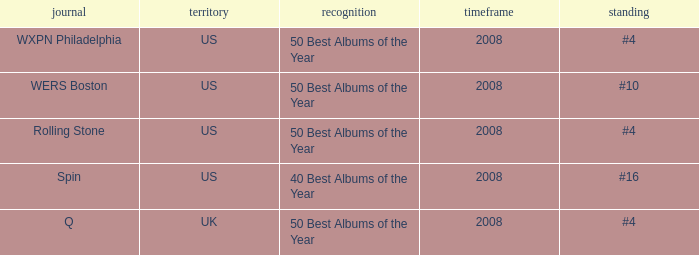Which year's rank was #4 when the country was the US? 2008, 2008. 